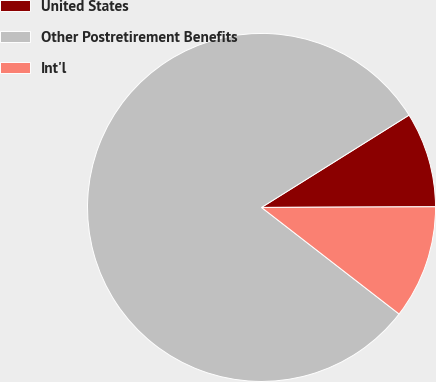<chart> <loc_0><loc_0><loc_500><loc_500><pie_chart><fcel>United States<fcel>Other Postretirement Benefits<fcel>Int'l<nl><fcel>8.84%<fcel>80.61%<fcel>10.55%<nl></chart> 